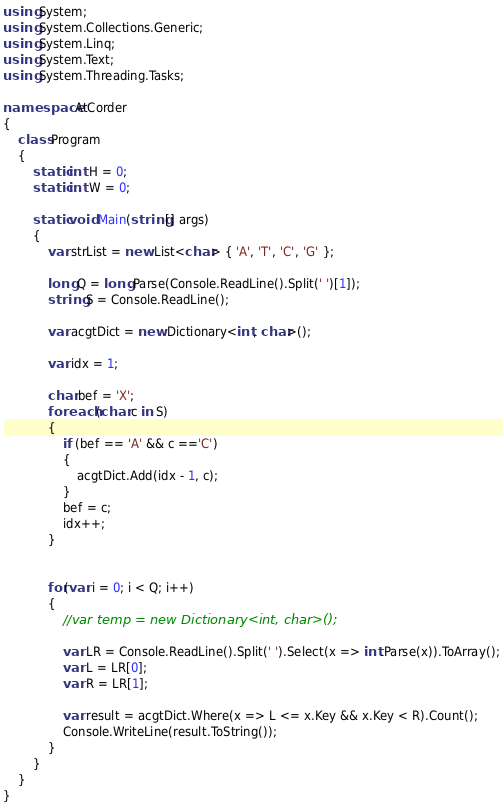Convert code to text. <code><loc_0><loc_0><loc_500><loc_500><_C#_>using System;
using System.Collections.Generic;
using System.Linq;
using System.Text;
using System.Threading.Tasks;

namespace AtCorder
{
    class Program
    {
        static int H = 0;
        static int W = 0;

        static void Main(string[] args)
        {
            var strList = new List<char> { 'A', 'T', 'C', 'G' };

            long Q = long.Parse(Console.ReadLine().Split(' ')[1]);
            string S = Console.ReadLine();

            var acgtDict = new Dictionary<int, char>();

            var idx = 1;

            char bef = 'X'; 
            foreach (char c in S)
            {
                if (bef == 'A' && c =='C')
                {
                    acgtDict.Add(idx - 1, c);
                }
                bef = c;
                idx++;
            }


            for(var i = 0; i < Q; i++)
            { 
                //var temp = new Dictionary<int, char>();

                var LR = Console.ReadLine().Split(' ').Select(x => int.Parse(x)).ToArray();
                var L = LR[0];
                var R = LR[1];

                var result = acgtDict.Where(x => L <= x.Key && x.Key < R).Count();
                Console.WriteLine(result.ToString());
            }
        }
    }
}</code> 